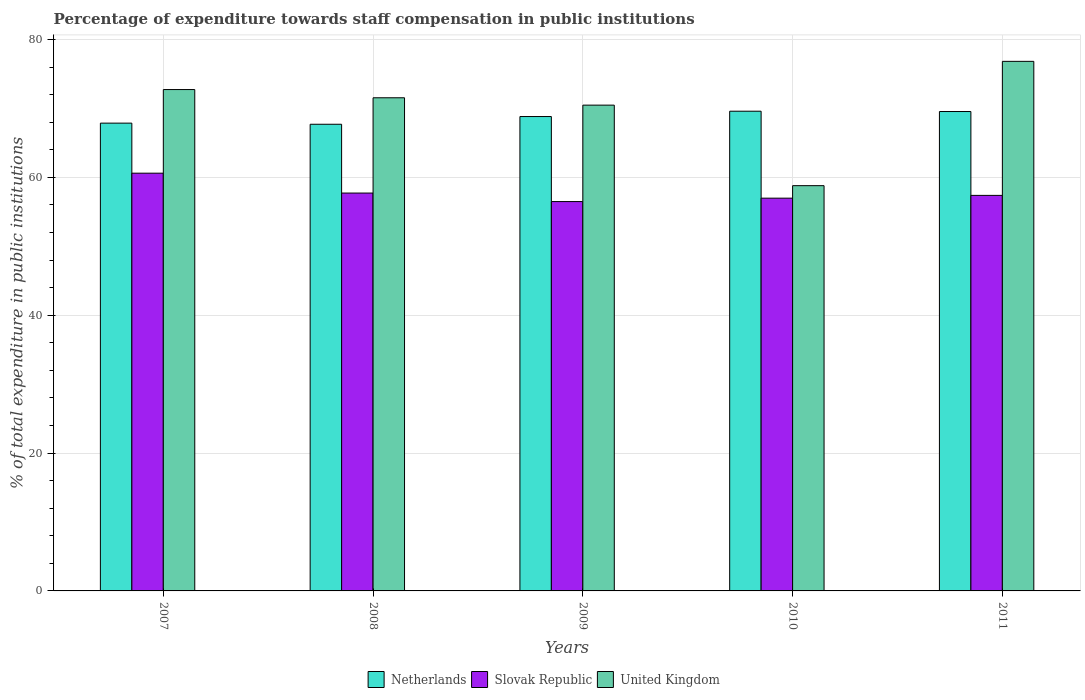Are the number of bars on each tick of the X-axis equal?
Keep it short and to the point. Yes. How many bars are there on the 4th tick from the right?
Your answer should be very brief. 3. In how many cases, is the number of bars for a given year not equal to the number of legend labels?
Ensure brevity in your answer.  0. What is the percentage of expenditure towards staff compensation in United Kingdom in 2007?
Provide a short and direct response. 72.73. Across all years, what is the maximum percentage of expenditure towards staff compensation in Slovak Republic?
Offer a terse response. 60.6. Across all years, what is the minimum percentage of expenditure towards staff compensation in Slovak Republic?
Provide a succinct answer. 56.48. In which year was the percentage of expenditure towards staff compensation in Netherlands maximum?
Your answer should be compact. 2010. In which year was the percentage of expenditure towards staff compensation in Netherlands minimum?
Ensure brevity in your answer.  2008. What is the total percentage of expenditure towards staff compensation in United Kingdom in the graph?
Give a very brief answer. 350.36. What is the difference between the percentage of expenditure towards staff compensation in Netherlands in 2007 and that in 2010?
Provide a succinct answer. -1.73. What is the difference between the percentage of expenditure towards staff compensation in Netherlands in 2007 and the percentage of expenditure towards staff compensation in United Kingdom in 2010?
Ensure brevity in your answer.  9.07. What is the average percentage of expenditure towards staff compensation in Slovak Republic per year?
Offer a very short reply. 57.83. In the year 2010, what is the difference between the percentage of expenditure towards staff compensation in United Kingdom and percentage of expenditure towards staff compensation in Slovak Republic?
Give a very brief answer. 1.81. What is the ratio of the percentage of expenditure towards staff compensation in Netherlands in 2008 to that in 2010?
Provide a short and direct response. 0.97. Is the percentage of expenditure towards staff compensation in United Kingdom in 2008 less than that in 2009?
Provide a succinct answer. No. Is the difference between the percentage of expenditure towards staff compensation in United Kingdom in 2008 and 2011 greater than the difference between the percentage of expenditure towards staff compensation in Slovak Republic in 2008 and 2011?
Offer a very short reply. No. What is the difference between the highest and the second highest percentage of expenditure towards staff compensation in Netherlands?
Make the answer very short. 0.04. What is the difference between the highest and the lowest percentage of expenditure towards staff compensation in Netherlands?
Offer a terse response. 1.89. In how many years, is the percentage of expenditure towards staff compensation in Slovak Republic greater than the average percentage of expenditure towards staff compensation in Slovak Republic taken over all years?
Your answer should be compact. 1. Is the sum of the percentage of expenditure towards staff compensation in Netherlands in 2009 and 2010 greater than the maximum percentage of expenditure towards staff compensation in Slovak Republic across all years?
Your response must be concise. Yes. What does the 2nd bar from the left in 2008 represents?
Ensure brevity in your answer.  Slovak Republic. What does the 2nd bar from the right in 2007 represents?
Your answer should be compact. Slovak Republic. How many years are there in the graph?
Your response must be concise. 5. What is the difference between two consecutive major ticks on the Y-axis?
Make the answer very short. 20. Does the graph contain any zero values?
Give a very brief answer. No. Where does the legend appear in the graph?
Ensure brevity in your answer.  Bottom center. What is the title of the graph?
Offer a terse response. Percentage of expenditure towards staff compensation in public institutions. Does "Argentina" appear as one of the legend labels in the graph?
Keep it short and to the point. No. What is the label or title of the X-axis?
Provide a short and direct response. Years. What is the label or title of the Y-axis?
Provide a succinct answer. % of total expenditure in public institutions. What is the % of total expenditure in public institutions of Netherlands in 2007?
Provide a short and direct response. 67.86. What is the % of total expenditure in public institutions of Slovak Republic in 2007?
Provide a short and direct response. 60.6. What is the % of total expenditure in public institutions in United Kingdom in 2007?
Offer a very short reply. 72.73. What is the % of total expenditure in public institutions in Netherlands in 2008?
Offer a terse response. 67.7. What is the % of total expenditure in public institutions in Slovak Republic in 2008?
Ensure brevity in your answer.  57.72. What is the % of total expenditure in public institutions in United Kingdom in 2008?
Make the answer very short. 71.54. What is the % of total expenditure in public institutions in Netherlands in 2009?
Your answer should be very brief. 68.82. What is the % of total expenditure in public institutions of Slovak Republic in 2009?
Your answer should be compact. 56.48. What is the % of total expenditure in public institutions in United Kingdom in 2009?
Offer a very short reply. 70.47. What is the % of total expenditure in public institutions of Netherlands in 2010?
Your answer should be compact. 69.59. What is the % of total expenditure in public institutions in Slovak Republic in 2010?
Your response must be concise. 56.98. What is the % of total expenditure in public institutions of United Kingdom in 2010?
Give a very brief answer. 58.79. What is the % of total expenditure in public institutions in Netherlands in 2011?
Your answer should be compact. 69.55. What is the % of total expenditure in public institutions in Slovak Republic in 2011?
Give a very brief answer. 57.38. What is the % of total expenditure in public institutions in United Kingdom in 2011?
Give a very brief answer. 76.82. Across all years, what is the maximum % of total expenditure in public institutions of Netherlands?
Your response must be concise. 69.59. Across all years, what is the maximum % of total expenditure in public institutions of Slovak Republic?
Keep it short and to the point. 60.6. Across all years, what is the maximum % of total expenditure in public institutions of United Kingdom?
Your answer should be very brief. 76.82. Across all years, what is the minimum % of total expenditure in public institutions of Netherlands?
Your answer should be very brief. 67.7. Across all years, what is the minimum % of total expenditure in public institutions of Slovak Republic?
Your answer should be very brief. 56.48. Across all years, what is the minimum % of total expenditure in public institutions of United Kingdom?
Provide a succinct answer. 58.79. What is the total % of total expenditure in public institutions of Netherlands in the graph?
Provide a short and direct response. 343.52. What is the total % of total expenditure in public institutions of Slovak Republic in the graph?
Make the answer very short. 289.16. What is the total % of total expenditure in public institutions in United Kingdom in the graph?
Make the answer very short. 350.36. What is the difference between the % of total expenditure in public institutions of Netherlands in 2007 and that in 2008?
Keep it short and to the point. 0.16. What is the difference between the % of total expenditure in public institutions of Slovak Republic in 2007 and that in 2008?
Provide a short and direct response. 2.88. What is the difference between the % of total expenditure in public institutions of United Kingdom in 2007 and that in 2008?
Give a very brief answer. 1.19. What is the difference between the % of total expenditure in public institutions in Netherlands in 2007 and that in 2009?
Give a very brief answer. -0.96. What is the difference between the % of total expenditure in public institutions in Slovak Republic in 2007 and that in 2009?
Your response must be concise. 4.12. What is the difference between the % of total expenditure in public institutions of United Kingdom in 2007 and that in 2009?
Offer a very short reply. 2.26. What is the difference between the % of total expenditure in public institutions of Netherlands in 2007 and that in 2010?
Keep it short and to the point. -1.73. What is the difference between the % of total expenditure in public institutions in Slovak Republic in 2007 and that in 2010?
Offer a terse response. 3.62. What is the difference between the % of total expenditure in public institutions in United Kingdom in 2007 and that in 2010?
Give a very brief answer. 13.94. What is the difference between the % of total expenditure in public institutions in Netherlands in 2007 and that in 2011?
Your answer should be very brief. -1.69. What is the difference between the % of total expenditure in public institutions in Slovak Republic in 2007 and that in 2011?
Your answer should be compact. 3.22. What is the difference between the % of total expenditure in public institutions of United Kingdom in 2007 and that in 2011?
Provide a succinct answer. -4.09. What is the difference between the % of total expenditure in public institutions of Netherlands in 2008 and that in 2009?
Ensure brevity in your answer.  -1.12. What is the difference between the % of total expenditure in public institutions in Slovak Republic in 2008 and that in 2009?
Ensure brevity in your answer.  1.24. What is the difference between the % of total expenditure in public institutions in United Kingdom in 2008 and that in 2009?
Your response must be concise. 1.07. What is the difference between the % of total expenditure in public institutions in Netherlands in 2008 and that in 2010?
Provide a succinct answer. -1.89. What is the difference between the % of total expenditure in public institutions in Slovak Republic in 2008 and that in 2010?
Provide a succinct answer. 0.74. What is the difference between the % of total expenditure in public institutions of United Kingdom in 2008 and that in 2010?
Offer a terse response. 12.75. What is the difference between the % of total expenditure in public institutions of Netherlands in 2008 and that in 2011?
Your answer should be compact. -1.85. What is the difference between the % of total expenditure in public institutions of Slovak Republic in 2008 and that in 2011?
Your answer should be very brief. 0.34. What is the difference between the % of total expenditure in public institutions in United Kingdom in 2008 and that in 2011?
Your response must be concise. -5.28. What is the difference between the % of total expenditure in public institutions of Netherlands in 2009 and that in 2010?
Provide a short and direct response. -0.77. What is the difference between the % of total expenditure in public institutions in Slovak Republic in 2009 and that in 2010?
Your answer should be very brief. -0.5. What is the difference between the % of total expenditure in public institutions of United Kingdom in 2009 and that in 2010?
Ensure brevity in your answer.  11.68. What is the difference between the % of total expenditure in public institutions of Netherlands in 2009 and that in 2011?
Ensure brevity in your answer.  -0.73. What is the difference between the % of total expenditure in public institutions of Slovak Republic in 2009 and that in 2011?
Make the answer very short. -0.9. What is the difference between the % of total expenditure in public institutions of United Kingdom in 2009 and that in 2011?
Provide a short and direct response. -6.35. What is the difference between the % of total expenditure in public institutions in Netherlands in 2010 and that in 2011?
Your answer should be compact. 0.04. What is the difference between the % of total expenditure in public institutions of Slovak Republic in 2010 and that in 2011?
Your answer should be compact. -0.4. What is the difference between the % of total expenditure in public institutions of United Kingdom in 2010 and that in 2011?
Make the answer very short. -18.03. What is the difference between the % of total expenditure in public institutions of Netherlands in 2007 and the % of total expenditure in public institutions of Slovak Republic in 2008?
Your answer should be compact. 10.14. What is the difference between the % of total expenditure in public institutions of Netherlands in 2007 and the % of total expenditure in public institutions of United Kingdom in 2008?
Provide a succinct answer. -3.68. What is the difference between the % of total expenditure in public institutions of Slovak Republic in 2007 and the % of total expenditure in public institutions of United Kingdom in 2008?
Your response must be concise. -10.94. What is the difference between the % of total expenditure in public institutions of Netherlands in 2007 and the % of total expenditure in public institutions of Slovak Republic in 2009?
Offer a terse response. 11.38. What is the difference between the % of total expenditure in public institutions in Netherlands in 2007 and the % of total expenditure in public institutions in United Kingdom in 2009?
Provide a succinct answer. -2.61. What is the difference between the % of total expenditure in public institutions in Slovak Republic in 2007 and the % of total expenditure in public institutions in United Kingdom in 2009?
Offer a very short reply. -9.87. What is the difference between the % of total expenditure in public institutions of Netherlands in 2007 and the % of total expenditure in public institutions of Slovak Republic in 2010?
Provide a short and direct response. 10.88. What is the difference between the % of total expenditure in public institutions of Netherlands in 2007 and the % of total expenditure in public institutions of United Kingdom in 2010?
Ensure brevity in your answer.  9.07. What is the difference between the % of total expenditure in public institutions of Slovak Republic in 2007 and the % of total expenditure in public institutions of United Kingdom in 2010?
Ensure brevity in your answer.  1.81. What is the difference between the % of total expenditure in public institutions of Netherlands in 2007 and the % of total expenditure in public institutions of Slovak Republic in 2011?
Your response must be concise. 10.48. What is the difference between the % of total expenditure in public institutions of Netherlands in 2007 and the % of total expenditure in public institutions of United Kingdom in 2011?
Make the answer very short. -8.96. What is the difference between the % of total expenditure in public institutions of Slovak Republic in 2007 and the % of total expenditure in public institutions of United Kingdom in 2011?
Your answer should be compact. -16.22. What is the difference between the % of total expenditure in public institutions in Netherlands in 2008 and the % of total expenditure in public institutions in Slovak Republic in 2009?
Offer a very short reply. 11.22. What is the difference between the % of total expenditure in public institutions in Netherlands in 2008 and the % of total expenditure in public institutions in United Kingdom in 2009?
Your answer should be compact. -2.77. What is the difference between the % of total expenditure in public institutions in Slovak Republic in 2008 and the % of total expenditure in public institutions in United Kingdom in 2009?
Make the answer very short. -12.75. What is the difference between the % of total expenditure in public institutions of Netherlands in 2008 and the % of total expenditure in public institutions of Slovak Republic in 2010?
Your answer should be very brief. 10.72. What is the difference between the % of total expenditure in public institutions in Netherlands in 2008 and the % of total expenditure in public institutions in United Kingdom in 2010?
Your response must be concise. 8.91. What is the difference between the % of total expenditure in public institutions of Slovak Republic in 2008 and the % of total expenditure in public institutions of United Kingdom in 2010?
Your answer should be compact. -1.07. What is the difference between the % of total expenditure in public institutions of Netherlands in 2008 and the % of total expenditure in public institutions of Slovak Republic in 2011?
Your response must be concise. 10.32. What is the difference between the % of total expenditure in public institutions of Netherlands in 2008 and the % of total expenditure in public institutions of United Kingdom in 2011?
Give a very brief answer. -9.12. What is the difference between the % of total expenditure in public institutions in Slovak Republic in 2008 and the % of total expenditure in public institutions in United Kingdom in 2011?
Your response must be concise. -19.11. What is the difference between the % of total expenditure in public institutions in Netherlands in 2009 and the % of total expenditure in public institutions in Slovak Republic in 2010?
Offer a very short reply. 11.84. What is the difference between the % of total expenditure in public institutions of Netherlands in 2009 and the % of total expenditure in public institutions of United Kingdom in 2010?
Give a very brief answer. 10.03. What is the difference between the % of total expenditure in public institutions of Slovak Republic in 2009 and the % of total expenditure in public institutions of United Kingdom in 2010?
Offer a terse response. -2.31. What is the difference between the % of total expenditure in public institutions in Netherlands in 2009 and the % of total expenditure in public institutions in Slovak Republic in 2011?
Your answer should be compact. 11.44. What is the difference between the % of total expenditure in public institutions of Netherlands in 2009 and the % of total expenditure in public institutions of United Kingdom in 2011?
Provide a succinct answer. -8.01. What is the difference between the % of total expenditure in public institutions of Slovak Republic in 2009 and the % of total expenditure in public institutions of United Kingdom in 2011?
Offer a terse response. -20.34. What is the difference between the % of total expenditure in public institutions in Netherlands in 2010 and the % of total expenditure in public institutions in Slovak Republic in 2011?
Your response must be concise. 12.21. What is the difference between the % of total expenditure in public institutions in Netherlands in 2010 and the % of total expenditure in public institutions in United Kingdom in 2011?
Your answer should be very brief. -7.23. What is the difference between the % of total expenditure in public institutions of Slovak Republic in 2010 and the % of total expenditure in public institutions of United Kingdom in 2011?
Provide a short and direct response. -19.85. What is the average % of total expenditure in public institutions of Netherlands per year?
Offer a very short reply. 68.7. What is the average % of total expenditure in public institutions in Slovak Republic per year?
Give a very brief answer. 57.83. What is the average % of total expenditure in public institutions in United Kingdom per year?
Your response must be concise. 70.07. In the year 2007, what is the difference between the % of total expenditure in public institutions of Netherlands and % of total expenditure in public institutions of Slovak Republic?
Your answer should be very brief. 7.26. In the year 2007, what is the difference between the % of total expenditure in public institutions in Netherlands and % of total expenditure in public institutions in United Kingdom?
Make the answer very short. -4.87. In the year 2007, what is the difference between the % of total expenditure in public institutions of Slovak Republic and % of total expenditure in public institutions of United Kingdom?
Offer a very short reply. -12.13. In the year 2008, what is the difference between the % of total expenditure in public institutions in Netherlands and % of total expenditure in public institutions in Slovak Republic?
Offer a terse response. 9.98. In the year 2008, what is the difference between the % of total expenditure in public institutions of Netherlands and % of total expenditure in public institutions of United Kingdom?
Your answer should be compact. -3.84. In the year 2008, what is the difference between the % of total expenditure in public institutions of Slovak Republic and % of total expenditure in public institutions of United Kingdom?
Keep it short and to the point. -13.82. In the year 2009, what is the difference between the % of total expenditure in public institutions in Netherlands and % of total expenditure in public institutions in Slovak Republic?
Offer a very short reply. 12.34. In the year 2009, what is the difference between the % of total expenditure in public institutions of Netherlands and % of total expenditure in public institutions of United Kingdom?
Provide a succinct answer. -1.66. In the year 2009, what is the difference between the % of total expenditure in public institutions in Slovak Republic and % of total expenditure in public institutions in United Kingdom?
Keep it short and to the point. -13.99. In the year 2010, what is the difference between the % of total expenditure in public institutions in Netherlands and % of total expenditure in public institutions in Slovak Republic?
Make the answer very short. 12.61. In the year 2010, what is the difference between the % of total expenditure in public institutions of Netherlands and % of total expenditure in public institutions of United Kingdom?
Offer a very short reply. 10.8. In the year 2010, what is the difference between the % of total expenditure in public institutions of Slovak Republic and % of total expenditure in public institutions of United Kingdom?
Provide a short and direct response. -1.81. In the year 2011, what is the difference between the % of total expenditure in public institutions of Netherlands and % of total expenditure in public institutions of Slovak Republic?
Your answer should be very brief. 12.17. In the year 2011, what is the difference between the % of total expenditure in public institutions of Netherlands and % of total expenditure in public institutions of United Kingdom?
Make the answer very short. -7.28. In the year 2011, what is the difference between the % of total expenditure in public institutions in Slovak Republic and % of total expenditure in public institutions in United Kingdom?
Keep it short and to the point. -19.44. What is the ratio of the % of total expenditure in public institutions in Netherlands in 2007 to that in 2008?
Make the answer very short. 1. What is the ratio of the % of total expenditure in public institutions in Slovak Republic in 2007 to that in 2008?
Make the answer very short. 1.05. What is the ratio of the % of total expenditure in public institutions of United Kingdom in 2007 to that in 2008?
Provide a short and direct response. 1.02. What is the ratio of the % of total expenditure in public institutions of Netherlands in 2007 to that in 2009?
Ensure brevity in your answer.  0.99. What is the ratio of the % of total expenditure in public institutions in Slovak Republic in 2007 to that in 2009?
Give a very brief answer. 1.07. What is the ratio of the % of total expenditure in public institutions in United Kingdom in 2007 to that in 2009?
Give a very brief answer. 1.03. What is the ratio of the % of total expenditure in public institutions in Netherlands in 2007 to that in 2010?
Give a very brief answer. 0.98. What is the ratio of the % of total expenditure in public institutions in Slovak Republic in 2007 to that in 2010?
Offer a very short reply. 1.06. What is the ratio of the % of total expenditure in public institutions of United Kingdom in 2007 to that in 2010?
Your answer should be compact. 1.24. What is the ratio of the % of total expenditure in public institutions of Netherlands in 2007 to that in 2011?
Provide a short and direct response. 0.98. What is the ratio of the % of total expenditure in public institutions in Slovak Republic in 2007 to that in 2011?
Give a very brief answer. 1.06. What is the ratio of the % of total expenditure in public institutions of United Kingdom in 2007 to that in 2011?
Offer a terse response. 0.95. What is the ratio of the % of total expenditure in public institutions of Netherlands in 2008 to that in 2009?
Your response must be concise. 0.98. What is the ratio of the % of total expenditure in public institutions in Slovak Republic in 2008 to that in 2009?
Give a very brief answer. 1.02. What is the ratio of the % of total expenditure in public institutions of United Kingdom in 2008 to that in 2009?
Keep it short and to the point. 1.02. What is the ratio of the % of total expenditure in public institutions of Netherlands in 2008 to that in 2010?
Give a very brief answer. 0.97. What is the ratio of the % of total expenditure in public institutions in United Kingdom in 2008 to that in 2010?
Make the answer very short. 1.22. What is the ratio of the % of total expenditure in public institutions of Netherlands in 2008 to that in 2011?
Your answer should be very brief. 0.97. What is the ratio of the % of total expenditure in public institutions of Slovak Republic in 2008 to that in 2011?
Make the answer very short. 1.01. What is the ratio of the % of total expenditure in public institutions of United Kingdom in 2008 to that in 2011?
Make the answer very short. 0.93. What is the ratio of the % of total expenditure in public institutions in Netherlands in 2009 to that in 2010?
Keep it short and to the point. 0.99. What is the ratio of the % of total expenditure in public institutions in Slovak Republic in 2009 to that in 2010?
Ensure brevity in your answer.  0.99. What is the ratio of the % of total expenditure in public institutions of United Kingdom in 2009 to that in 2010?
Your response must be concise. 1.2. What is the ratio of the % of total expenditure in public institutions of Netherlands in 2009 to that in 2011?
Offer a very short reply. 0.99. What is the ratio of the % of total expenditure in public institutions in Slovak Republic in 2009 to that in 2011?
Provide a succinct answer. 0.98. What is the ratio of the % of total expenditure in public institutions in United Kingdom in 2009 to that in 2011?
Make the answer very short. 0.92. What is the ratio of the % of total expenditure in public institutions of Netherlands in 2010 to that in 2011?
Provide a short and direct response. 1. What is the ratio of the % of total expenditure in public institutions of United Kingdom in 2010 to that in 2011?
Your answer should be very brief. 0.77. What is the difference between the highest and the second highest % of total expenditure in public institutions of Netherlands?
Offer a very short reply. 0.04. What is the difference between the highest and the second highest % of total expenditure in public institutions in Slovak Republic?
Keep it short and to the point. 2.88. What is the difference between the highest and the second highest % of total expenditure in public institutions in United Kingdom?
Provide a short and direct response. 4.09. What is the difference between the highest and the lowest % of total expenditure in public institutions of Netherlands?
Your response must be concise. 1.89. What is the difference between the highest and the lowest % of total expenditure in public institutions in Slovak Republic?
Offer a very short reply. 4.12. What is the difference between the highest and the lowest % of total expenditure in public institutions of United Kingdom?
Provide a short and direct response. 18.03. 